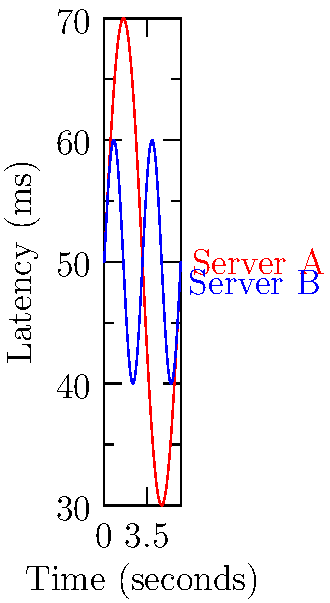In the performance graph above, two sine waves represent network latency fluctuations for different servers over time. The red line (Server A) follows the equation $y = 50 + 20\sin(x)$, while the blue line (Server B) follows $y = 50 + 10\sin(2x)$, where $y$ is latency in milliseconds and $x$ is time in seconds. At what time interval (in seconds) does Server B complete a full latency cycle compared to Server A? To solve this problem, we need to compare the periods of the two sine waves:

1. For Server A: $y = 50 + 20\sin(x)$
   The period of this function is $2\pi$ seconds, as it completes one full cycle every $2\pi$ seconds.

2. For Server B: $y = 50 + 10\sin(2x)$
   The period of this function is $\pi$ seconds, because:
   a) The general form of a sine function is $a\sin(bx)$, where the period is $\frac{2\pi}{|b|}$.
   b) In this case, $b = 2$, so the period is $\frac{2\pi}{2} = \pi$ seconds.

3. To find how often Server B completes a full cycle compared to Server A:
   $\frac{\text{Period of Server A}}{\text{Period of Server B}} = \frac{2\pi}{\pi} = 2$

Therefore, Server B completes two full cycles in the time it takes Server A to complete one cycle.
Answer: $\pi$ seconds 